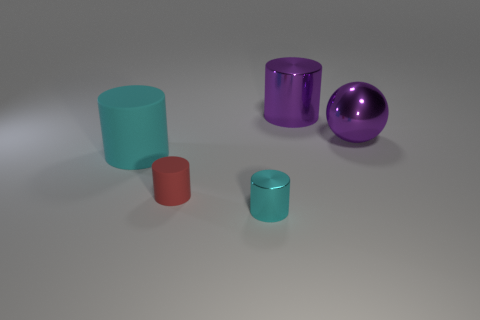How many big objects are either blue rubber cylinders or purple metal cylinders?
Give a very brief answer. 1. Is the number of large blue metallic cubes less than the number of large spheres?
Offer a very short reply. Yes. Is there anything else that has the same size as the red thing?
Offer a very short reply. Yes. Do the large matte cylinder and the tiny rubber cylinder have the same color?
Give a very brief answer. No. Is the number of tiny red cylinders greater than the number of large cyan metallic balls?
Provide a short and direct response. Yes. What number of other objects are the same color as the large metallic cylinder?
Give a very brief answer. 1. There is a cylinder that is right of the tiny cyan metallic cylinder; what number of large purple metallic balls are right of it?
Ensure brevity in your answer.  1. Are there any big shiny objects on the left side of the purple metallic cylinder?
Your answer should be very brief. No. There is a large purple thing that is on the right side of the large purple metallic cylinder that is on the right side of the tiny red cylinder; what shape is it?
Offer a very short reply. Sphere. Is the number of cyan metal things that are to the left of the large cyan matte object less than the number of purple metallic cylinders right of the purple metal cylinder?
Keep it short and to the point. No. 